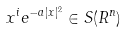<formula> <loc_0><loc_0><loc_500><loc_500>x ^ { i } e ^ { - a | x | ^ { 2 } } \in S ( R ^ { n } )</formula> 